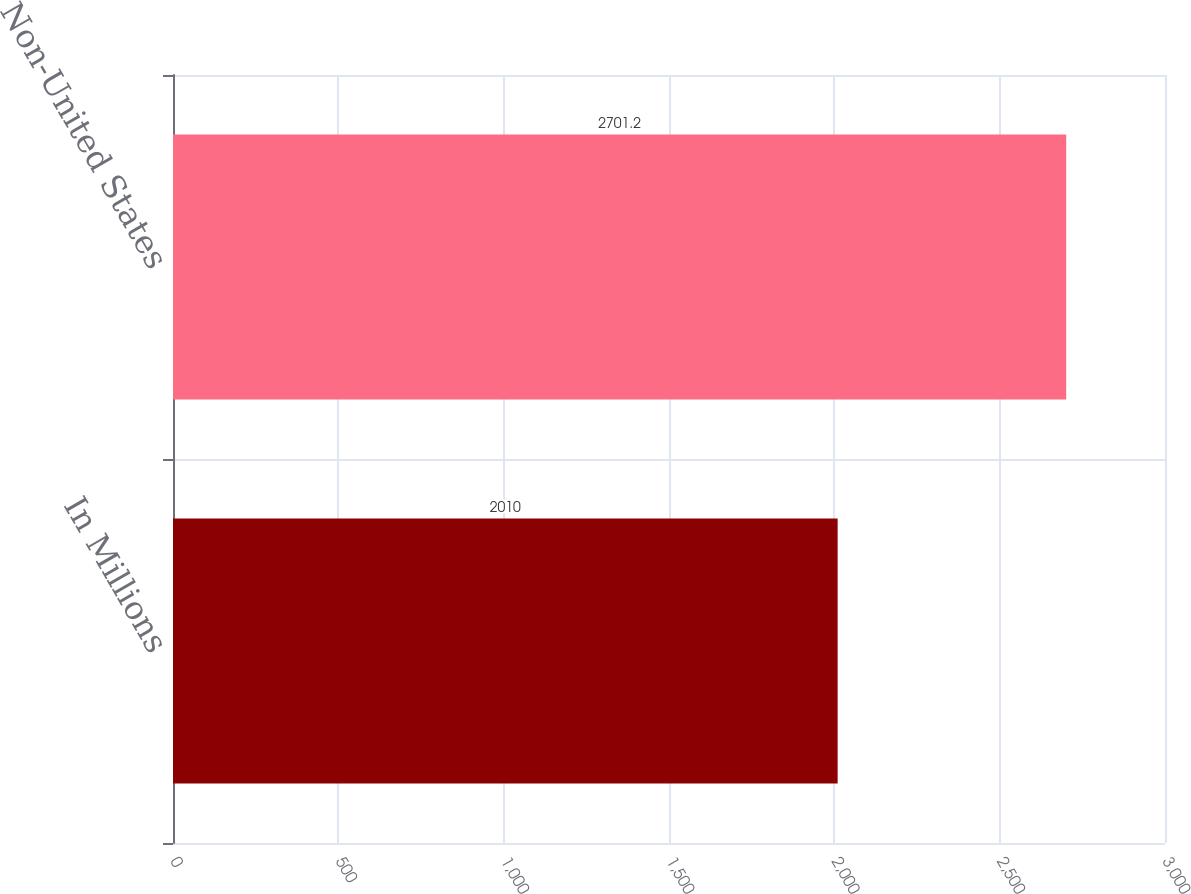Convert chart to OTSL. <chart><loc_0><loc_0><loc_500><loc_500><bar_chart><fcel>In Millions<fcel>Non-United States<nl><fcel>2010<fcel>2701.2<nl></chart> 